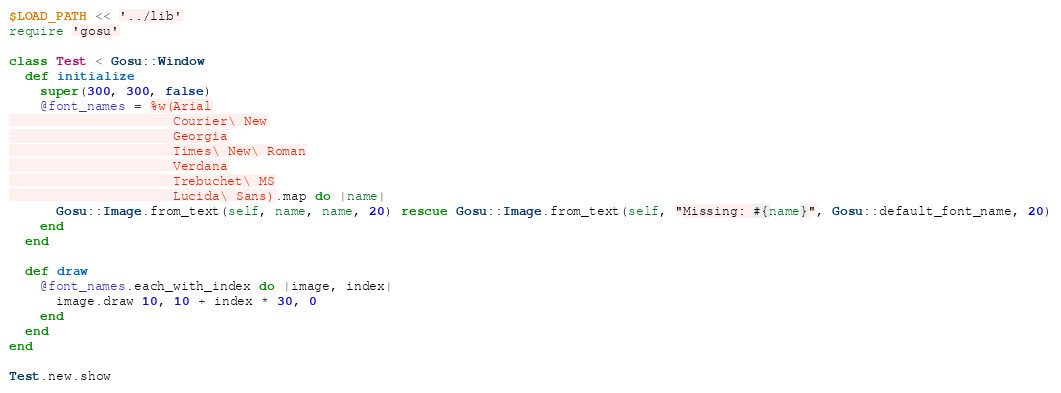<code> <loc_0><loc_0><loc_500><loc_500><_Ruby_>$LOAD_PATH << '../lib'
require 'gosu'

class Test < Gosu::Window
  def initialize
    super(300, 300, false)
    @font_names = %w(Arial
                     Courier\ New
                     Georgia
                     Times\ New\ Roman
                     Verdana
                     Trebuchet\ MS
                     Lucida\ Sans).map do |name|
      Gosu::Image.from_text(self, name, name, 20) rescue Gosu::Image.from_text(self, "Missing: #{name}", Gosu::default_font_name, 20)
    end
  end

  def draw
    @font_names.each_with_index do |image, index|
      image.draw 10, 10 + index * 30, 0
    end
  end
end

Test.new.show
</code> 